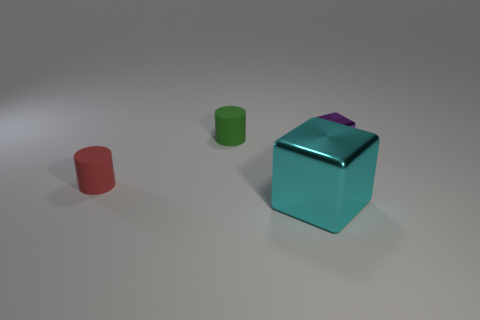Add 4 cylinders. How many objects exist? 8 Subtract all small blocks. Subtract all tiny red matte objects. How many objects are left? 2 Add 2 purple shiny cubes. How many purple shiny cubes are left? 3 Add 2 large yellow blocks. How many large yellow blocks exist? 2 Subtract 0 gray balls. How many objects are left? 4 